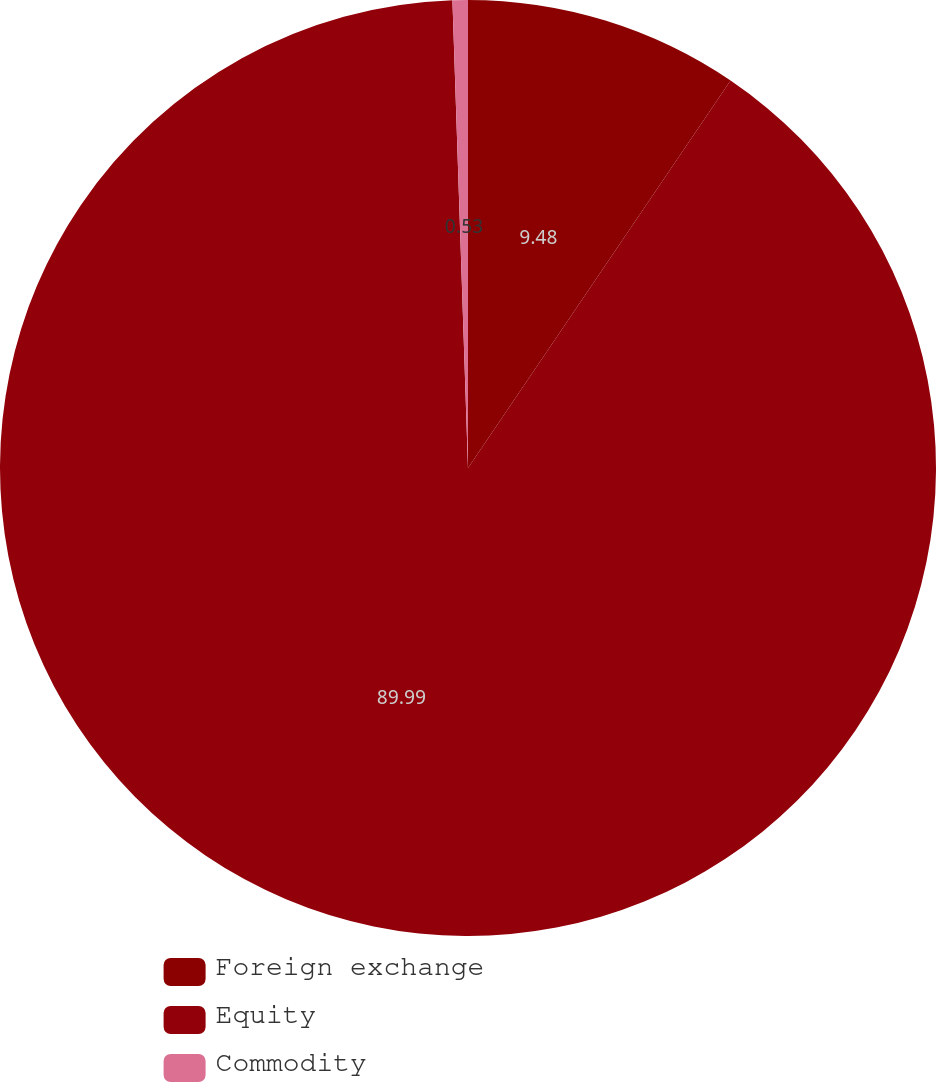Convert chart to OTSL. <chart><loc_0><loc_0><loc_500><loc_500><pie_chart><fcel>Foreign exchange<fcel>Equity<fcel>Commodity<nl><fcel>9.48%<fcel>89.99%<fcel>0.53%<nl></chart> 